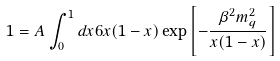Convert formula to latex. <formula><loc_0><loc_0><loc_500><loc_500>1 = A \int _ { 0 } ^ { 1 } d x 6 x ( 1 - x ) \exp { \left [ - \frac { \beta ^ { 2 } m _ { q } ^ { 2 } } { x ( 1 - x ) } \right ] }</formula> 